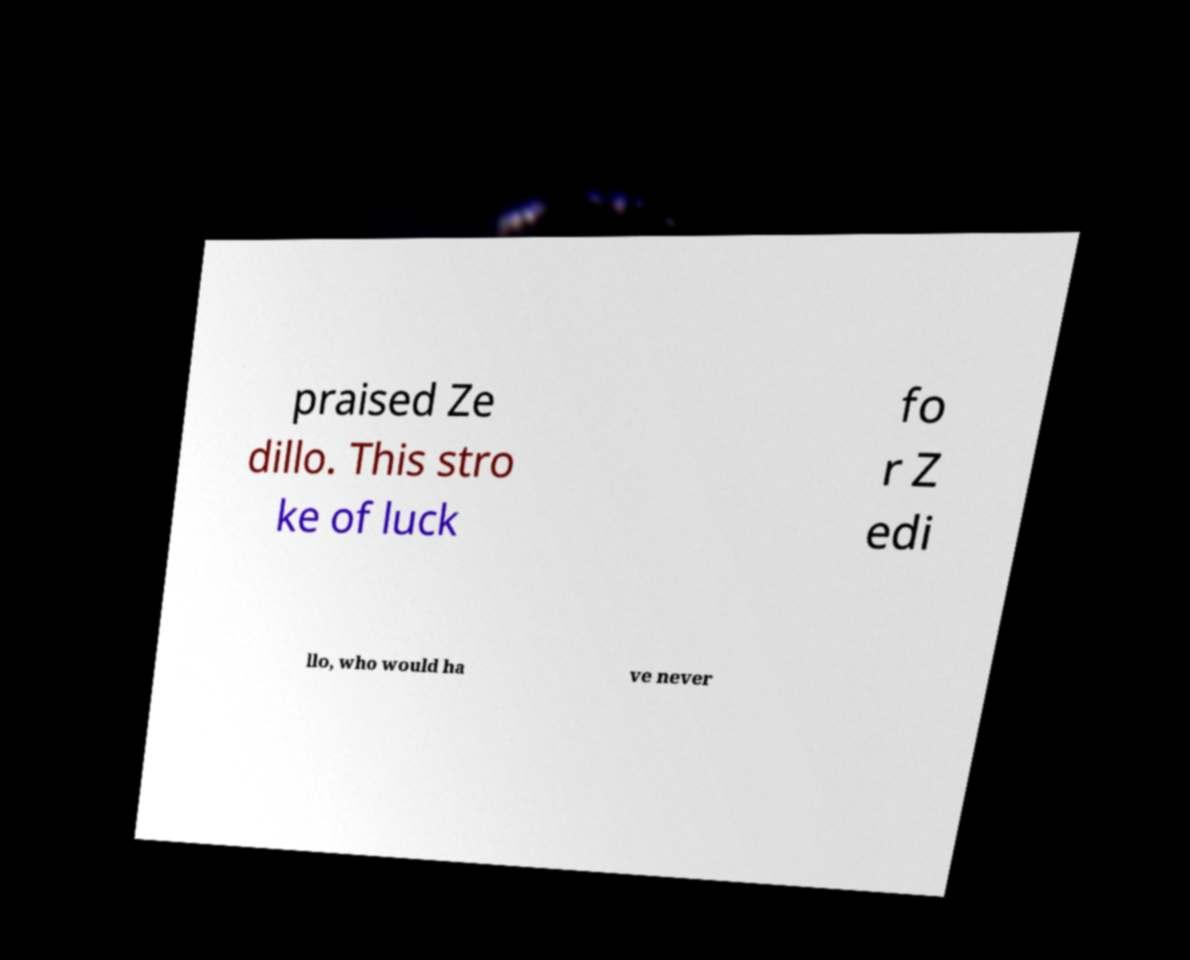For documentation purposes, I need the text within this image transcribed. Could you provide that? praised Ze dillo. This stro ke of luck fo r Z edi llo, who would ha ve never 